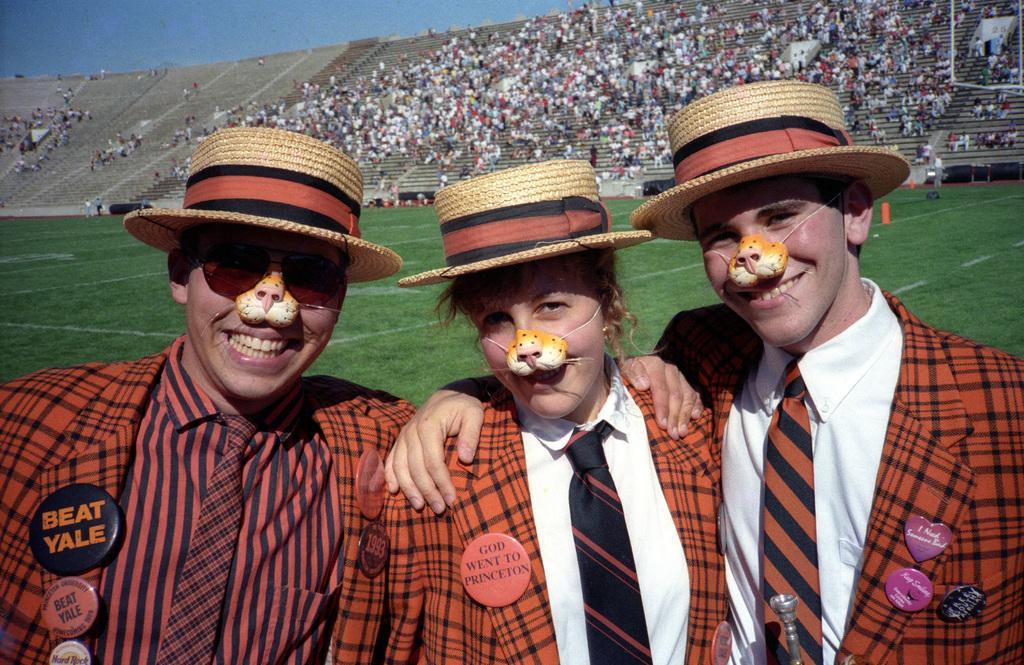In one or two sentences, can you explain what this image depicts? In this picture there are three persons, who are wearing suit, hat and plastic tiger nose. In the background we can see audience who are sitting on the stadium. Here we can see stairs. On the left we can see grass on the ground. On the top there is a sky. 